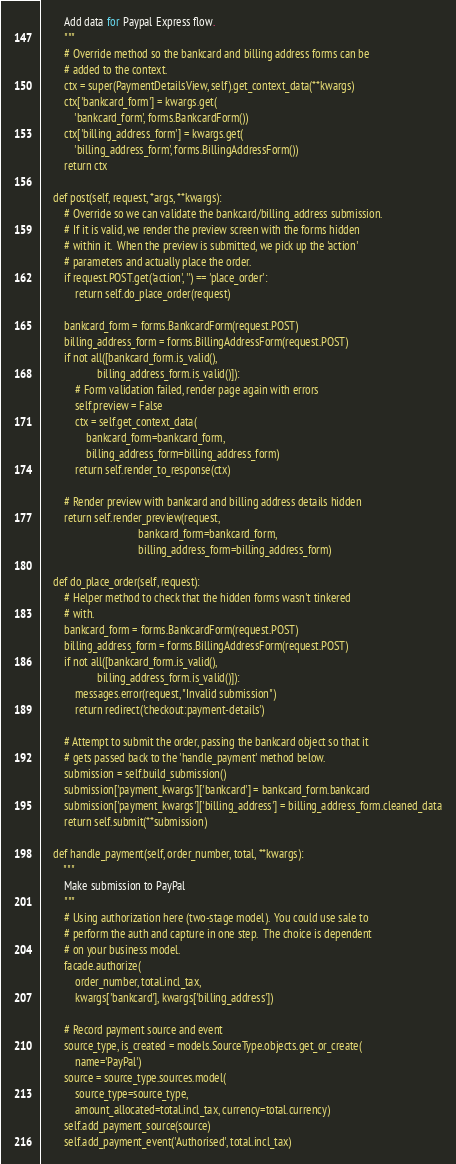Convert code to text. <code><loc_0><loc_0><loc_500><loc_500><_Python_>        Add data for Paypal Express flow.
        """
        # Override method so the bankcard and billing address forms can be
        # added to the context.
        ctx = super(PaymentDetailsView, self).get_context_data(**kwargs)
        ctx['bankcard_form'] = kwargs.get(
            'bankcard_form', forms.BankcardForm())
        ctx['billing_address_form'] = kwargs.get(
            'billing_address_form', forms.BillingAddressForm())
        return ctx

    def post(self, request, *args, **kwargs):
        # Override so we can validate the bankcard/billing_address submission.
        # If it is valid, we render the preview screen with the forms hidden
        # within it.  When the preview is submitted, we pick up the 'action'
        # parameters and actually place the order.
        if request.POST.get('action', '') == 'place_order':
            return self.do_place_order(request)

        bankcard_form = forms.BankcardForm(request.POST)
        billing_address_form = forms.BillingAddressForm(request.POST)
        if not all([bankcard_form.is_valid(),
                    billing_address_form.is_valid()]):
            # Form validation failed, render page again with errors
            self.preview = False
            ctx = self.get_context_data(
                bankcard_form=bankcard_form,
                billing_address_form=billing_address_form)
            return self.render_to_response(ctx)

        # Render preview with bankcard and billing address details hidden
        return self.render_preview(request,
                                   bankcard_form=bankcard_form,
                                   billing_address_form=billing_address_form)

    def do_place_order(self, request):
        # Helper method to check that the hidden forms wasn't tinkered
        # with.
        bankcard_form = forms.BankcardForm(request.POST)
        billing_address_form = forms.BillingAddressForm(request.POST)
        if not all([bankcard_form.is_valid(),
                    billing_address_form.is_valid()]):
            messages.error(request, "Invalid submission")
            return redirect('checkout:payment-details')

        # Attempt to submit the order, passing the bankcard object so that it
        # gets passed back to the 'handle_payment' method below.
        submission = self.build_submission()
        submission['payment_kwargs']['bankcard'] = bankcard_form.bankcard
        submission['payment_kwargs']['billing_address'] = billing_address_form.cleaned_data
        return self.submit(**submission)

    def handle_payment(self, order_number, total, **kwargs):
        """
        Make submission to PayPal
        """
        # Using authorization here (two-stage model).  You could use sale to
        # perform the auth and capture in one step.  The choice is dependent
        # on your business model.
        facade.authorize(
            order_number, total.incl_tax,
            kwargs['bankcard'], kwargs['billing_address'])

        # Record payment source and event
        source_type, is_created = models.SourceType.objects.get_or_create(
            name='PayPal')
        source = source_type.sources.model(
            source_type=source_type,
            amount_allocated=total.incl_tax, currency=total.currency)
        self.add_payment_source(source)
        self.add_payment_event('Authorised', total.incl_tax)
</code> 